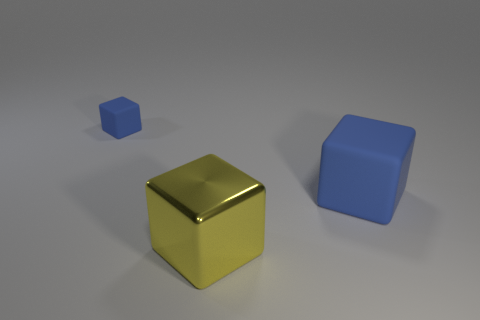How many other objects are there of the same color as the large metal block?
Offer a very short reply. 0. Is the color of the rubber object that is left of the big yellow metal cube the same as the matte cube in front of the tiny blue cube?
Offer a terse response. Yes. Is there any other thing that is the same material as the big yellow block?
Provide a succinct answer. No. There is another metal object that is the same shape as the small blue thing; what size is it?
Offer a very short reply. Large. Are the blue object that is right of the tiny blue block and the tiny blue thing made of the same material?
Provide a succinct answer. Yes. There is a blue object that is left of the block that is in front of the blue rubber cube that is right of the metallic cube; what is its size?
Ensure brevity in your answer.  Small. There is another blue block that is the same material as the big blue block; what size is it?
Make the answer very short. Small. There is a block that is both to the right of the tiny blue cube and behind the big yellow cube; what color is it?
Give a very brief answer. Blue. There is a big cube that is left of the large blue block; what is its material?
Your response must be concise. Metal. There is a matte block that is the same color as the big rubber object; what is its size?
Make the answer very short. Small. 